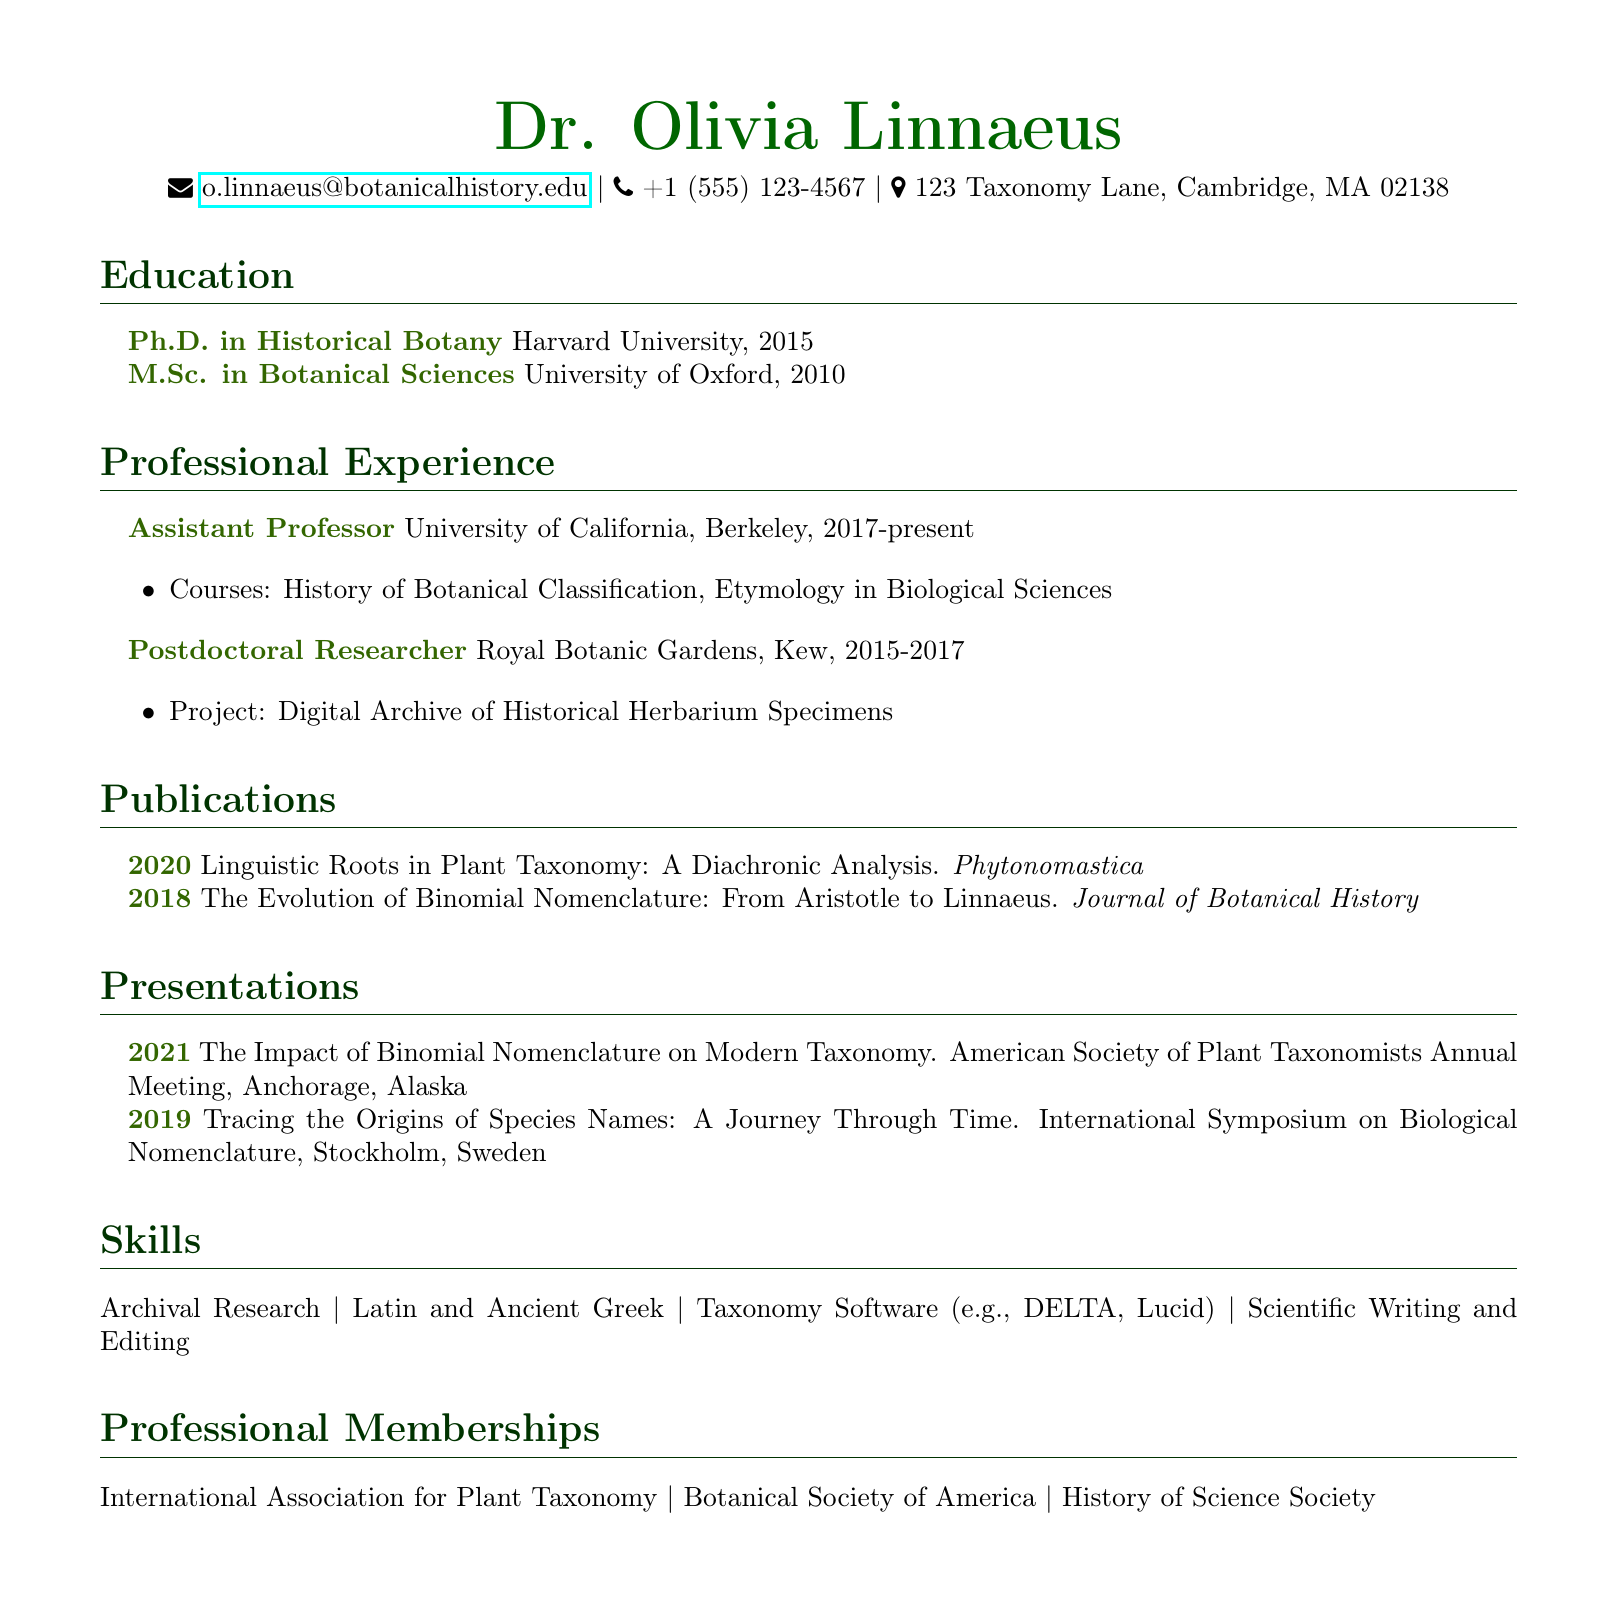what is the name of the academic? The document lists the name of the academic as Dr. Olivia Linnaeus.
Answer: Dr. Olivia Linnaeus which journal published the 2018 paper? The publication titled "The Evolution of Binomial Nomenclature: From Aristotle to Linnaeus" was published in the Journal of Botanical History.
Answer: Journal of Botanical History what position does Dr. Linnaeus hold at the University of California, Berkeley? The document states that Dr. Linnaeus is an Assistant Professor at the University of California, Berkeley.
Answer: Assistant Professor how many publications are listed in the CV? The document contains a total of two publications by Dr. Linnaeus.
Answer: 2 what was the title of the presentation given in Stockholm? The presentation titled "Tracing the Origins of Species Names: A Journey Through Time" was presented in Stockholm.
Answer: Tracing the Origins of Species Names: A Journey Through Time in which year did Dr. Linnaeus complete her Ph.D.? The document indicates that Dr. Linnaeus completed her Ph.D. in 2015.
Answer: 2015 what is one skill mentioned in the CV? The document lists "Archival Research" as one of the skills of Dr. Linnaeus.
Answer: Archival Research how many professional memberships does Dr. Linnaeus have? The document mentions three professional memberships held by Dr. Linnaeus.
Answer: 3 